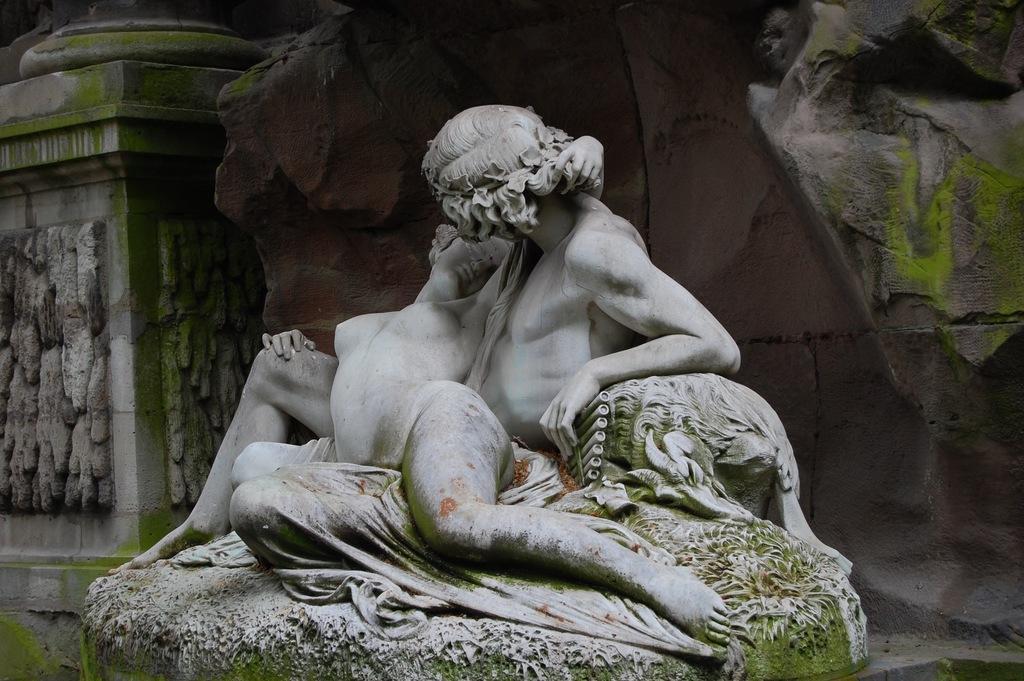Describe this image in one or two sentences. In this image I can see a statue of two persons which is green and white in color. In the background I can see a huge rock and a pillar which is ash and green in color. 